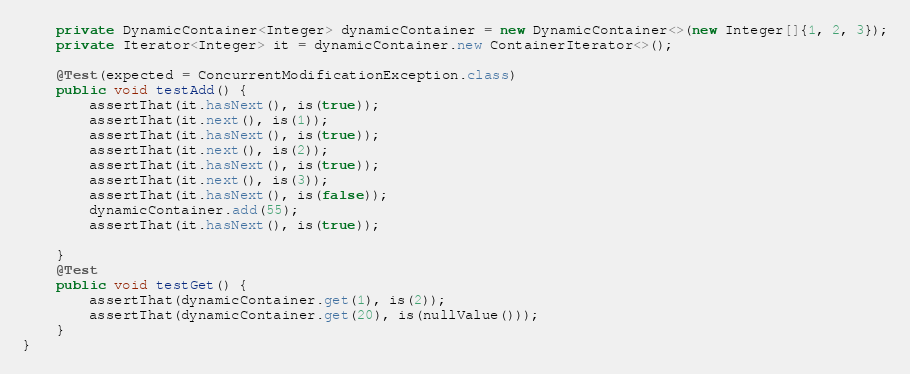Convert code to text. <code><loc_0><loc_0><loc_500><loc_500><_Java_>    private DynamicContainer<Integer> dynamicContainer = new DynamicContainer<>(new Integer[]{1, 2, 3});
    private Iterator<Integer> it = dynamicContainer.new ContainerIterator<>();

    @Test(expected = ConcurrentModificationException.class)
    public void testAdd() {
        assertThat(it.hasNext(), is(true));
        assertThat(it.next(), is(1));
        assertThat(it.hasNext(), is(true));
        assertThat(it.next(), is(2));
        assertThat(it.hasNext(), is(true));
        assertThat(it.next(), is(3));
        assertThat(it.hasNext(), is(false));
        dynamicContainer.add(55);
        assertThat(it.hasNext(), is(true));

    }
    @Test
    public void testGet() {
        assertThat(dynamicContainer.get(1), is(2));
        assertThat(dynamicContainer.get(20), is(nullValue()));
    }
}</code> 